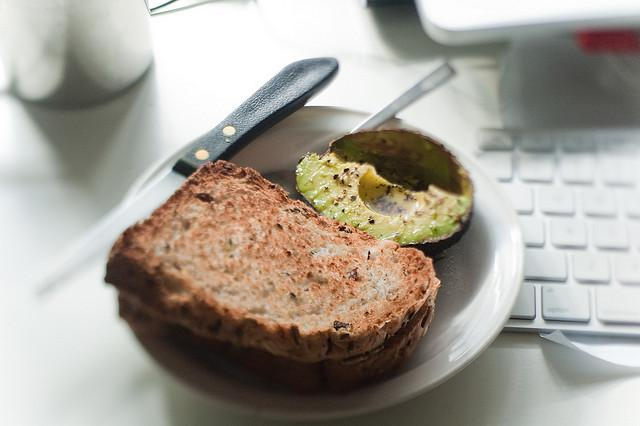What is going on the toast? avocado 